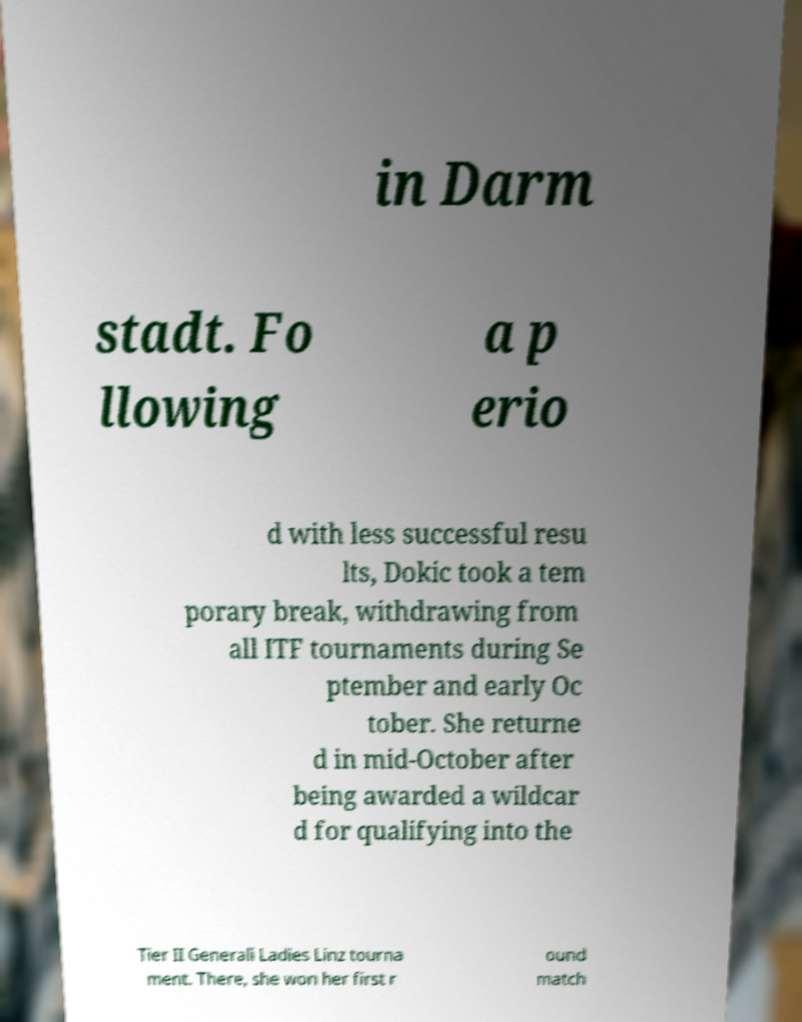Could you assist in decoding the text presented in this image and type it out clearly? in Darm stadt. Fo llowing a p erio d with less successful resu lts, Dokic took a tem porary break, withdrawing from all ITF tournaments during Se ptember and early Oc tober. She returne d in mid-October after being awarded a wildcar d for qualifying into the Tier II Generali Ladies Linz tourna ment. There, she won her first r ound match 